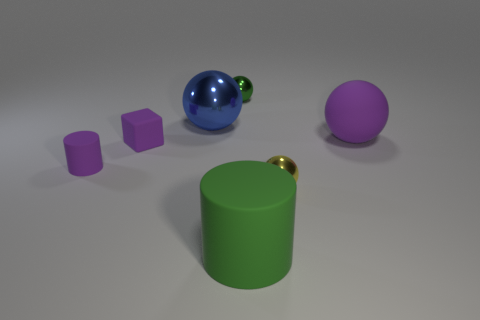What number of things are tiny objects in front of the tiny block or metal objects behind the tiny purple matte cube?
Give a very brief answer. 4. What is the material of the other sphere that is the same size as the yellow metallic ball?
Make the answer very short. Metal. The small matte cube has what color?
Ensure brevity in your answer.  Purple. What is the material of the purple object that is right of the tiny cylinder and left of the blue metal ball?
Your answer should be very brief. Rubber. Are there any green spheres that are on the right side of the green cylinder in front of the matte cylinder behind the tiny yellow ball?
Your response must be concise. No. There is a ball that is the same color as the small matte cylinder; what is its size?
Ensure brevity in your answer.  Large. There is a tiny green metallic ball; are there any matte balls left of it?
Provide a succinct answer. No. How many other things are there of the same shape as the tiny green object?
Ensure brevity in your answer.  3. The metallic thing that is the same size as the purple rubber ball is what color?
Provide a succinct answer. Blue. Are there fewer purple rubber cylinders to the right of the large green rubber cylinder than big metal spheres in front of the yellow object?
Your response must be concise. No. 